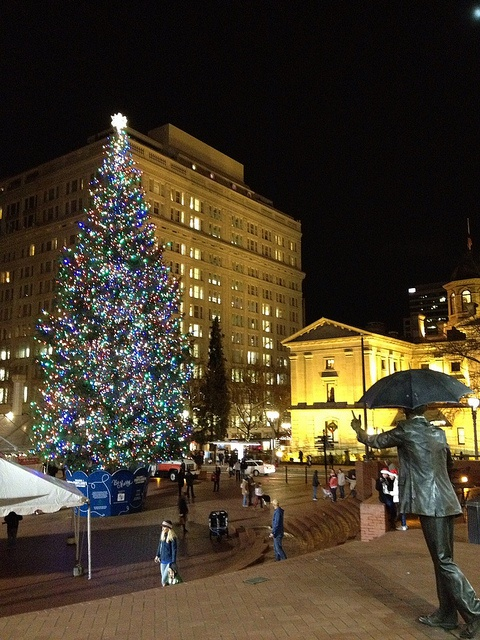Describe the objects in this image and their specific colors. I can see people in black, gray, and darkgreen tones, people in black, maroon, and gray tones, umbrella in black, gray, and purple tones, people in black, gray, navy, and blue tones, and people in black, navy, gray, and darkblue tones in this image. 